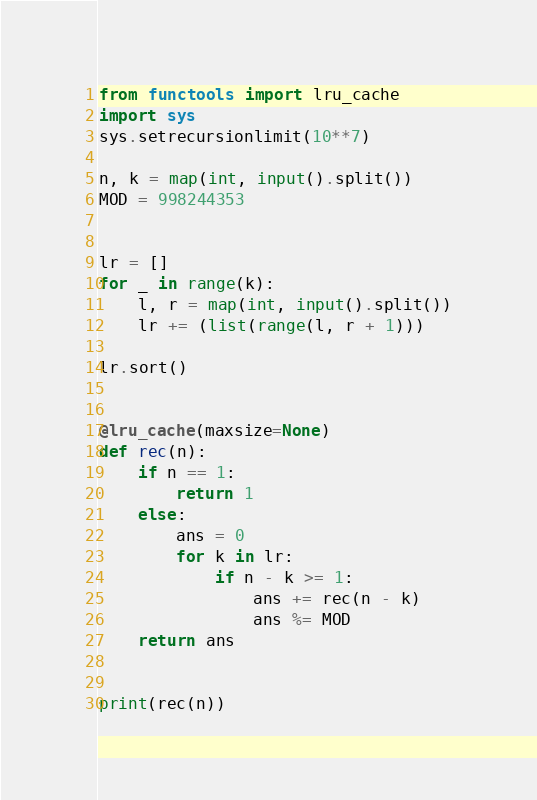Convert code to text. <code><loc_0><loc_0><loc_500><loc_500><_Python_>from functools import lru_cache
import sys
sys.setrecursionlimit(10**7)

n, k = map(int, input().split())
MOD = 998244353


lr = []
for _ in range(k):
    l, r = map(int, input().split())
    lr += (list(range(l, r + 1)))

lr.sort()


@lru_cache(maxsize=None)
def rec(n):
    if n == 1:
        return 1
    else:
        ans = 0
        for k in lr:
            if n - k >= 1:
                ans += rec(n - k)
                ans %= MOD
    return ans


print(rec(n))</code> 